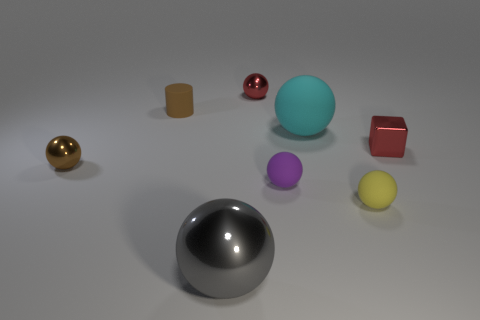What is the size of the metal object that is the same color as the small block?
Provide a succinct answer. Small. Are there any yellow rubber spheres that are in front of the tiny metal sphere that is left of the small red metallic thing that is left of the red metal block?
Provide a succinct answer. Yes. Are there any shiny spheres on the right side of the large gray metallic thing?
Give a very brief answer. Yes. There is a red shiny thing to the right of the purple object; what number of red shiny things are on the left side of it?
Keep it short and to the point. 1. There is a yellow matte thing; is its size the same as the metal thing in front of the yellow thing?
Your answer should be compact. No. Is there a tiny sphere of the same color as the tiny cylinder?
Offer a very short reply. Yes. What size is the cyan thing that is the same material as the tiny yellow ball?
Your answer should be compact. Large. Is the purple ball made of the same material as the brown sphere?
Give a very brief answer. No. What is the color of the small metallic sphere that is in front of the metallic object to the right of the tiny red thing to the left of the purple ball?
Your answer should be very brief. Brown. What is the shape of the brown shiny object?
Provide a short and direct response. Sphere. 